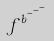Convert formula to latex. <formula><loc_0><loc_0><loc_500><loc_500>f ^ { b ^ { c ^ { - ^ { - ^ { - } } } } }</formula> 